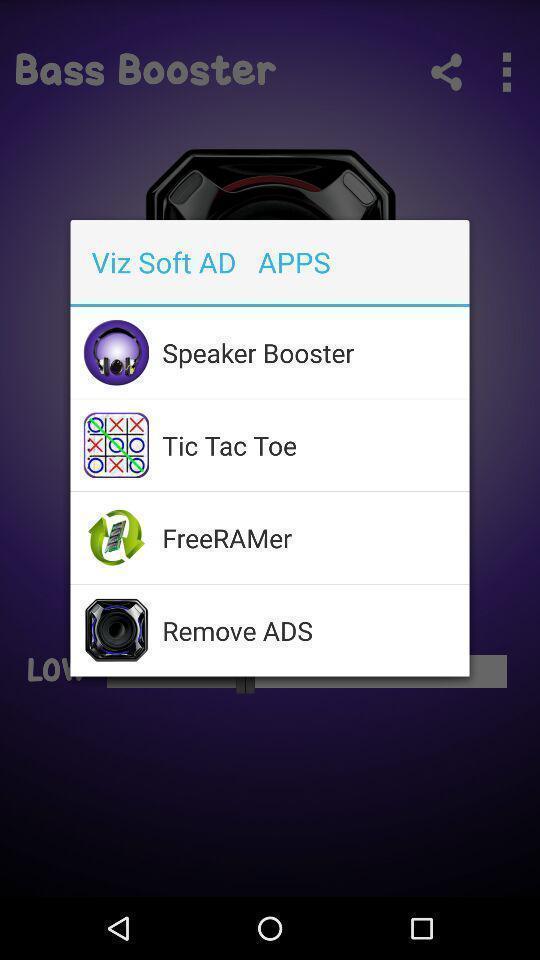Tell me about the visual elements in this screen capture. Pop up page for adds of different apps. 